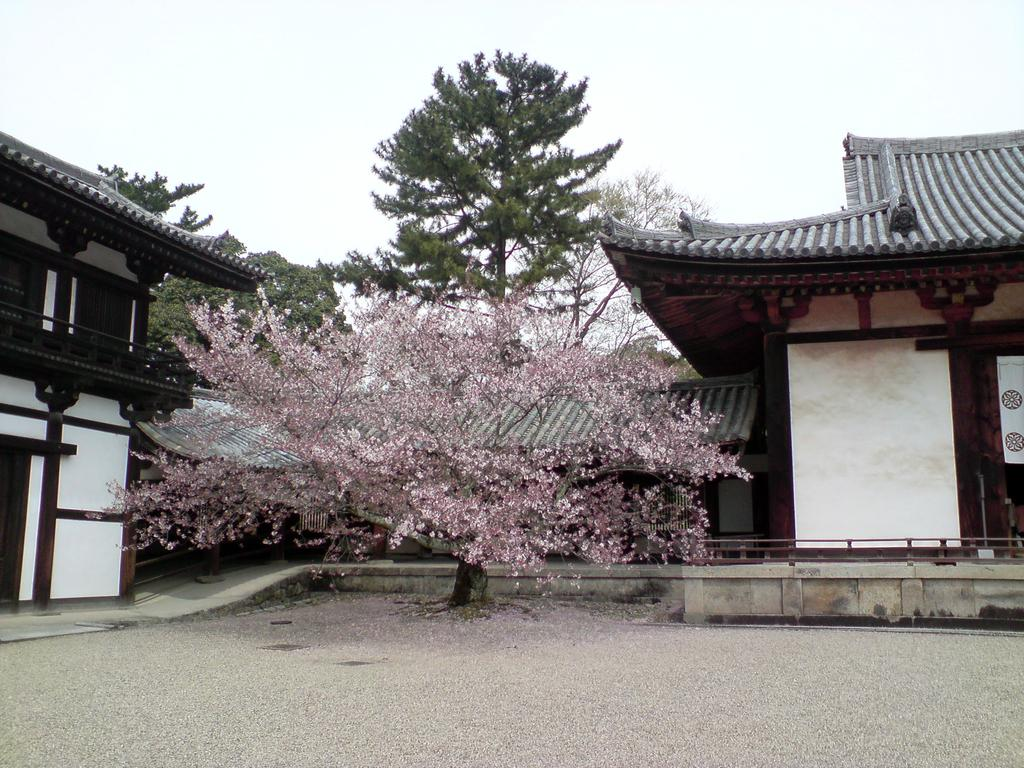What type of structures can be seen in the image? There are buildings in the image. What other natural elements are present in the image? There are trees in the image. What is the condition of the sky in the image? The sky is clear in the image. What mathematical operation is being performed on the buildings in the image? There is no mathematical operation being performed on the buildings in the image. Can you see a hose being used in the image? There is no hose present in the image. 